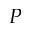Convert formula to latex. <formula><loc_0><loc_0><loc_500><loc_500>P</formula> 